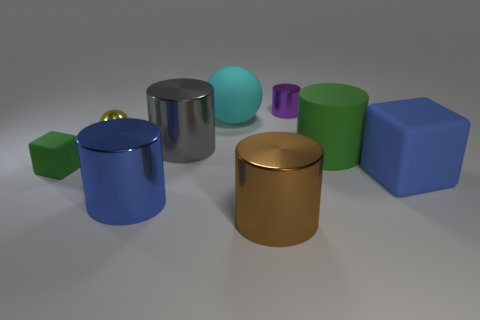Subtract all purple shiny cylinders. How many cylinders are left? 4 Subtract all cyan spheres. How many spheres are left? 1 Subtract 3 cylinders. How many cylinders are left? 2 Subtract all yellow metal things. Subtract all purple metal cylinders. How many objects are left? 7 Add 8 cyan rubber things. How many cyan rubber things are left? 9 Add 2 blue shiny things. How many blue shiny things exist? 3 Subtract 0 gray blocks. How many objects are left? 9 Subtract all cubes. How many objects are left? 7 Subtract all cyan spheres. Subtract all cyan cylinders. How many spheres are left? 1 Subtract all cyan cylinders. How many gray spheres are left? 0 